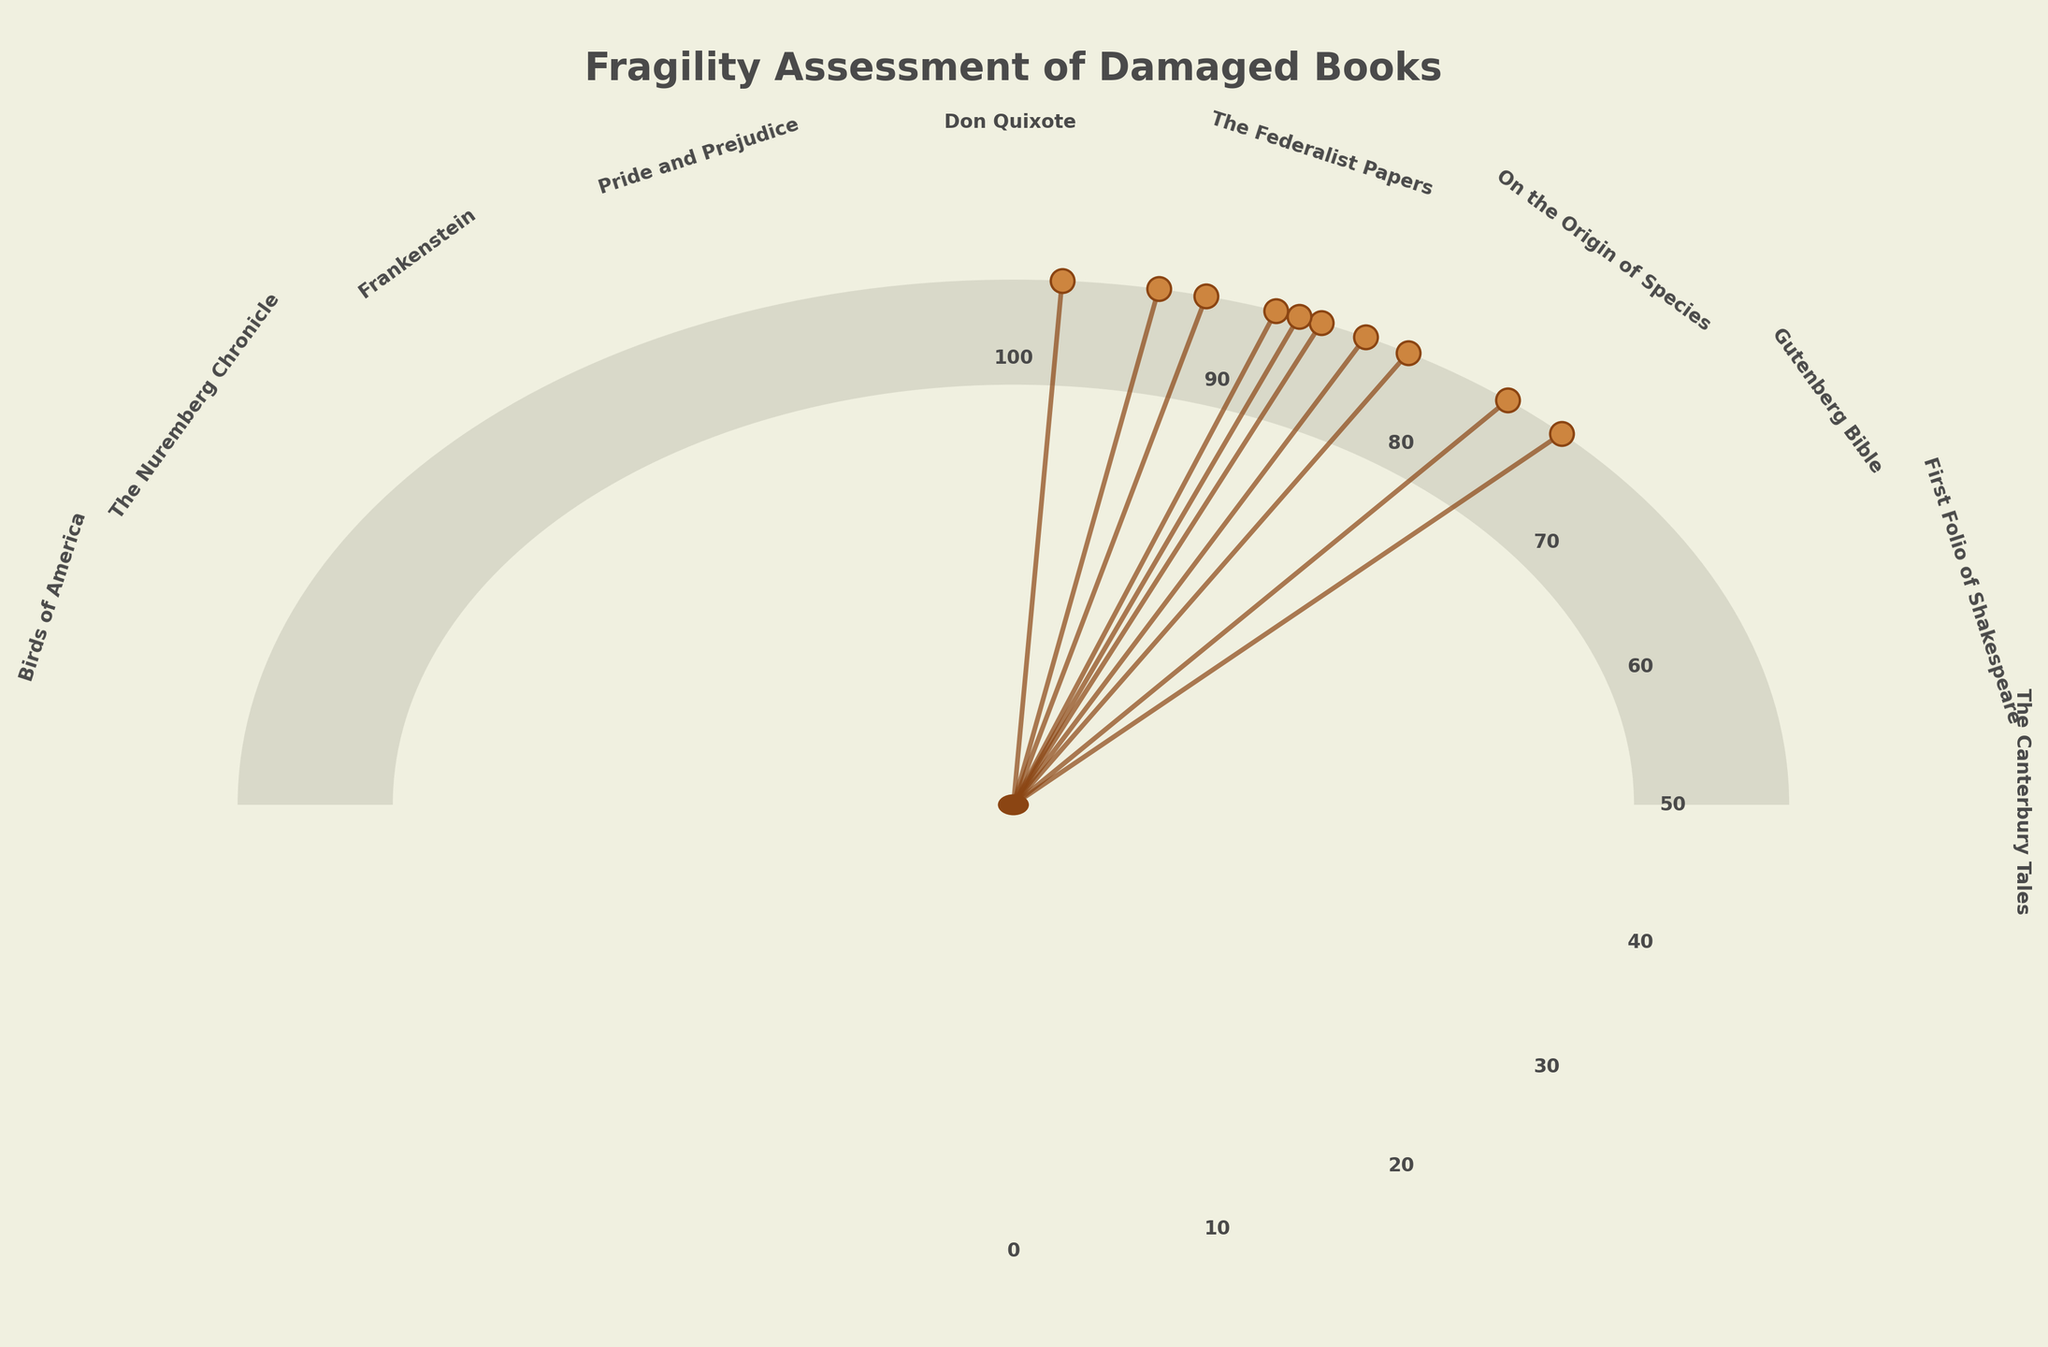How many books are assessed in the fragility chart? Count the number of data points or labels present on the chart. Each title represents an assessed book.
Answer: 10 What is the title of the book with the highest fragility score? Identify the data point at the highest end of the gauge. Look for the highest positioned label.
Answer: Gutenberg Bible Which book has the lowest fragility score? Identify the data point closest to the lowest end of the gauge. Check the labels for the lowest score.
Answer: Pride and Prejudice What is the average fragility score of all the books? Sum all the fragility scores and divide by the number of books. Scores: 92, 85, 98, 78, 83, 89, 75, 87, 94, 88. Average = (92+85+98+78+83+89+75+87+94+88)/10 = 869/10
Answer: 86.9 Which two books have the closest fragility scores? Compare the scores of each book and find the pair with the smallest difference. Compare scores visually or calculate the differences.
Answer: First Folio of Shakespeare and The Federalist Papers (Difference of 2) How many books have a fragility score above 90? Count the number of data points that lie above the score of 90 on the gauge.
Answer: 3 What is the fragility score range of the books? Identify the highest and lowest fragility scores and find their difference. Highest score: 98, Lowest score: 75. Range = 98 - 75 = 23
Answer: 23 Which books have a fragility score between 80 and 90? Identify data points lying between 80 and 90 on the gauge. Check their labels.
Answer: First Folio of Shakespeare, The Federalist Papers, Don Quixote, Frankenstein, Birds of America What is the difference in fragility score between "The Canterbury Tales" and "Pride and Prejudice"? Subtract the fragility score of "Pride and Prejudice" from "The Canterbury Tales". Difference = 92 - 75
Answer: 17 